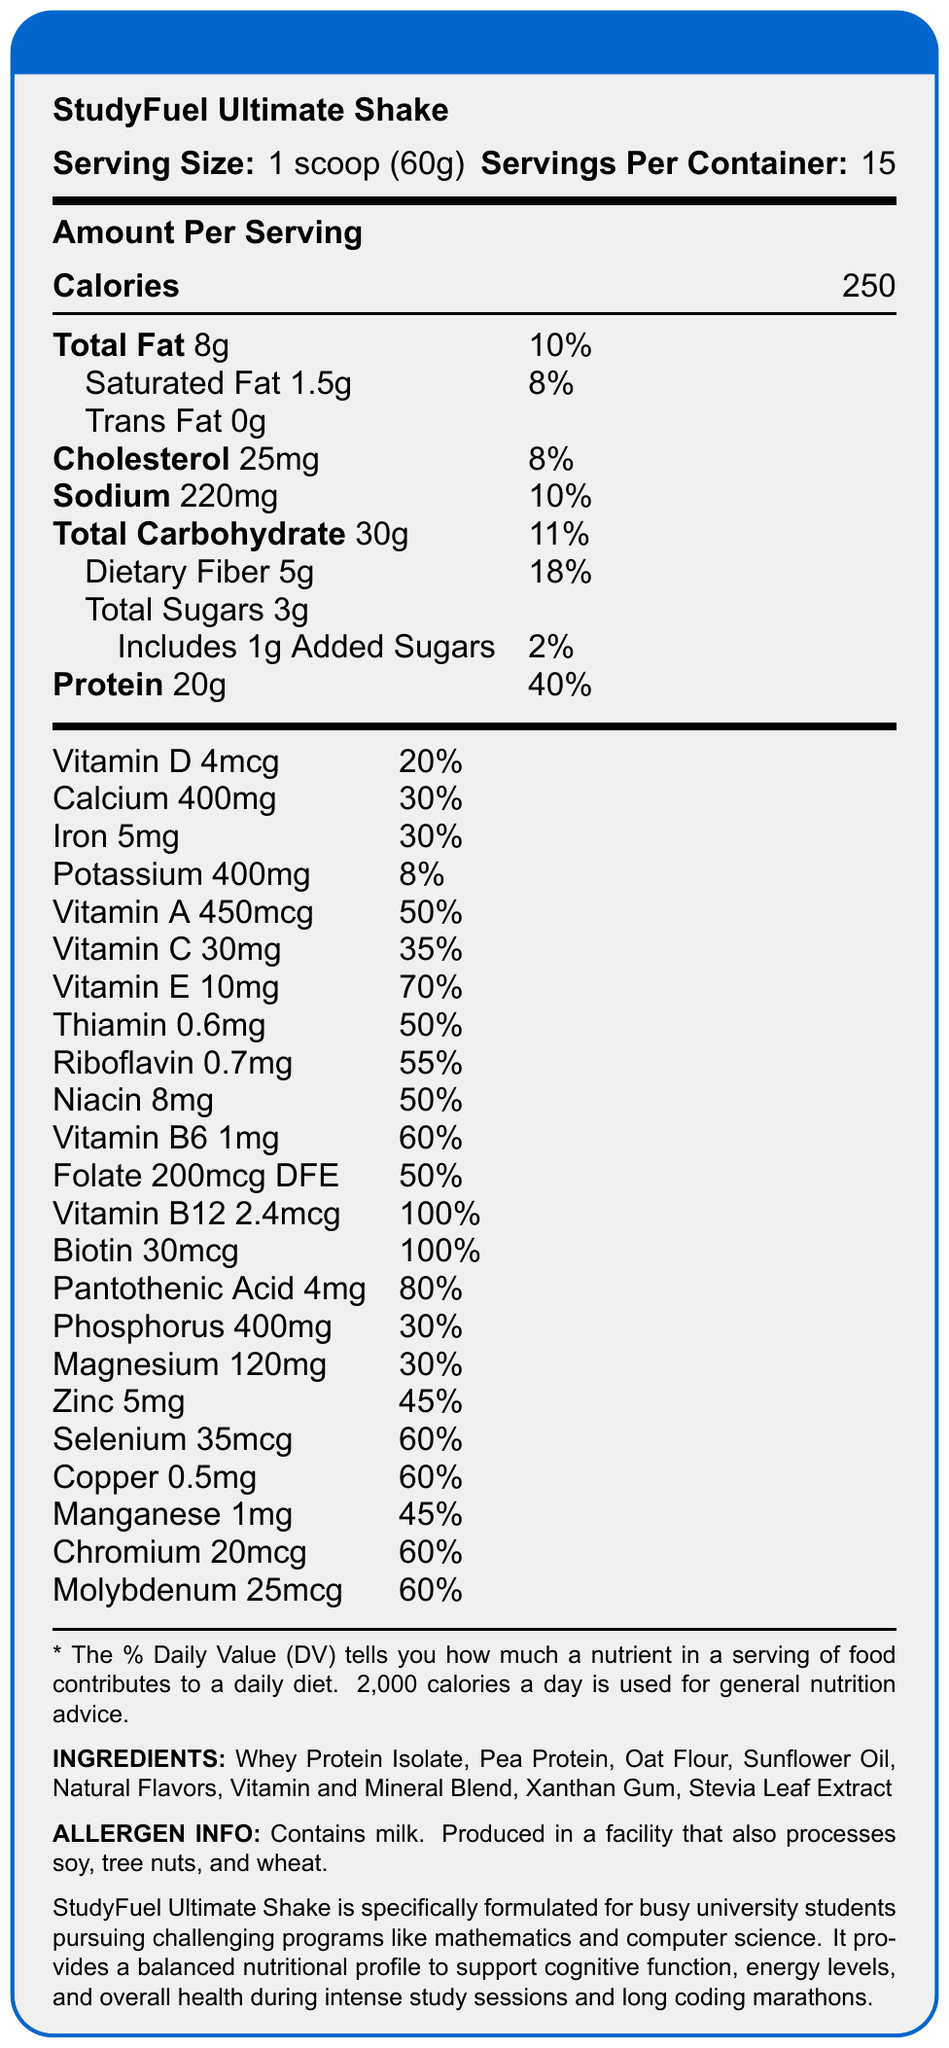How many servings are there per container of the StudyFuel Ultimate Shake? The document states "Servings Per Container: 15".
Answer: 15 What is the total amount of protein in one serving of the StudyFuel Ultimate Shake? Under "Amount Per Serving", it lists "Protein 20g".
Answer: 20g What is the percentage daily value of Vitamin D in one serving? The document lists "Vitamin D 4mcg" with a daily value of 20%.
Answer: 20% Which two types of protein does the StudyFuel Ultimate Shake contain? In the "INGREDIENTS" section, it lists "Whey Protein Isolate, Pea Protein".
Answer: Whey Protein Isolate and Pea Protein What is the total carbohydrate content per serving? Under "Amount Per Serving", "Total Carbohydrate 30g" is mentioned.
Answer: 30g Does the StudyFuel Ultimate Shake contain trans fat? The document clearly states "Trans Fat 0g".
Answer: No What is the allergen information for the StudyFuel Ultimate Shake? The allergen information is provided at the bottom of the document.
Answer: Contains milk. Produced in a facility that also processes soy, tree nuts, and wheat. What is the main purpose of the StudyFuel Ultimate Shake as mentioned in the document? The "product_description" section mentions that the shake is specifically formulated for busy university students pursuing challenging programs like mathematics and computer science to support cognitive function, energy levels, and overall health.
Answer: It is formulated for busy university students to support cognitive function, energy levels, and overall health during intense study sessions and long coding marathons. What ingredient is used as a sweetener in the StudyFuel Ultimate Shake? In the "INGREDIENTS" section, "Stevia Leaf Extract" is listed.
Answer: Stevia Leaf Extract How much Vitamin B12 is in one serving and what is its percentage daily value? A. 1.2mcg, 50% B. 2.4mcg, 100% C. 3.0mcg, 80% The document lists "Vitamin B12 2.4mcg" with a daily value of 100%.
Answer: B. 2.4mcg, 100% Which of the following minerals in the StudyFuel Ultimate Shake has a daily value percentage of 30%? A. Phosphorus B. Zinc C. Selenium The document lists "Phosphorus 400mg" with a daily value of 30%.
Answer: A. Phosphorus Does the StudyFuel Ultimate Shake contain any iron? The document lists "Iron 5mg" with a daily value of 30%.
Answer: Yes Summarize the nutritional benefits of the StudyFuel Ultimate Shake mentioned in the document. The document is a Nutrition Facts label for the StudyFuel Ultimate Shake, which offers detailed information on its nutrient content per serving and describes its purpose to support university students' demanding schedules.
Answer: The StudyFuel Ultimate Shake provides a balanced nutritional profile aimed at supporting cognitive function, energy levels, and overall health. It contains 250 calories per serving, high protein content (20g), a range of essential vitamins and minerals, and is designed for busy university students. Key nutrients include vitamins A, C, D, E, B12, and minerals like calcium, iron, and magnesium. How many grams of added sugars are in one serving of the StudyFuel Ultimate Shake? Under "Total Carbohydrate", it mentions "Includes 1g Added Sugars".
Answer: 1g What kinds of flavors are used in the StudyFuel Ultimate Shake? In the "INGREDIENTS" section, it lists "Natural Flavors".
Answer: Natural Flavors What are the ingredients listed in the Vitamin and Mineral Blend? The document lists "Vitamin and Mineral Blend" as one of the ingredients, but it does not provide specific details about the components of this blend.
Answer: Cannot be determined 